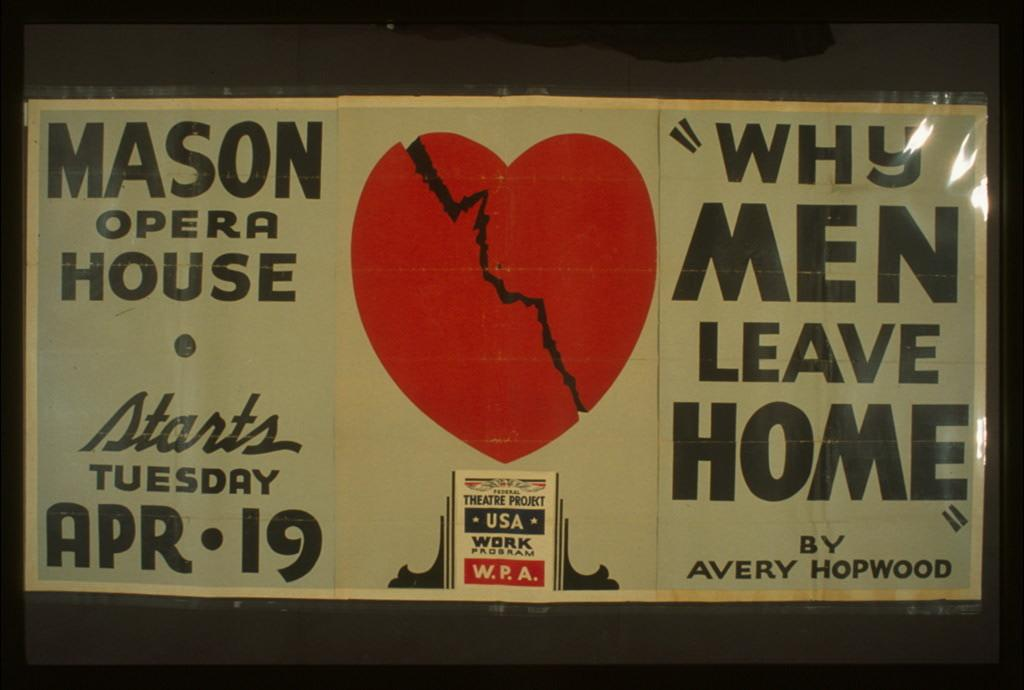<image>
Share a concise interpretation of the image provided. A sign for Mason Opera House starts Tuesday, April 19 with a heart broken in half and a quote of "why men leave home" by avery hopwood 